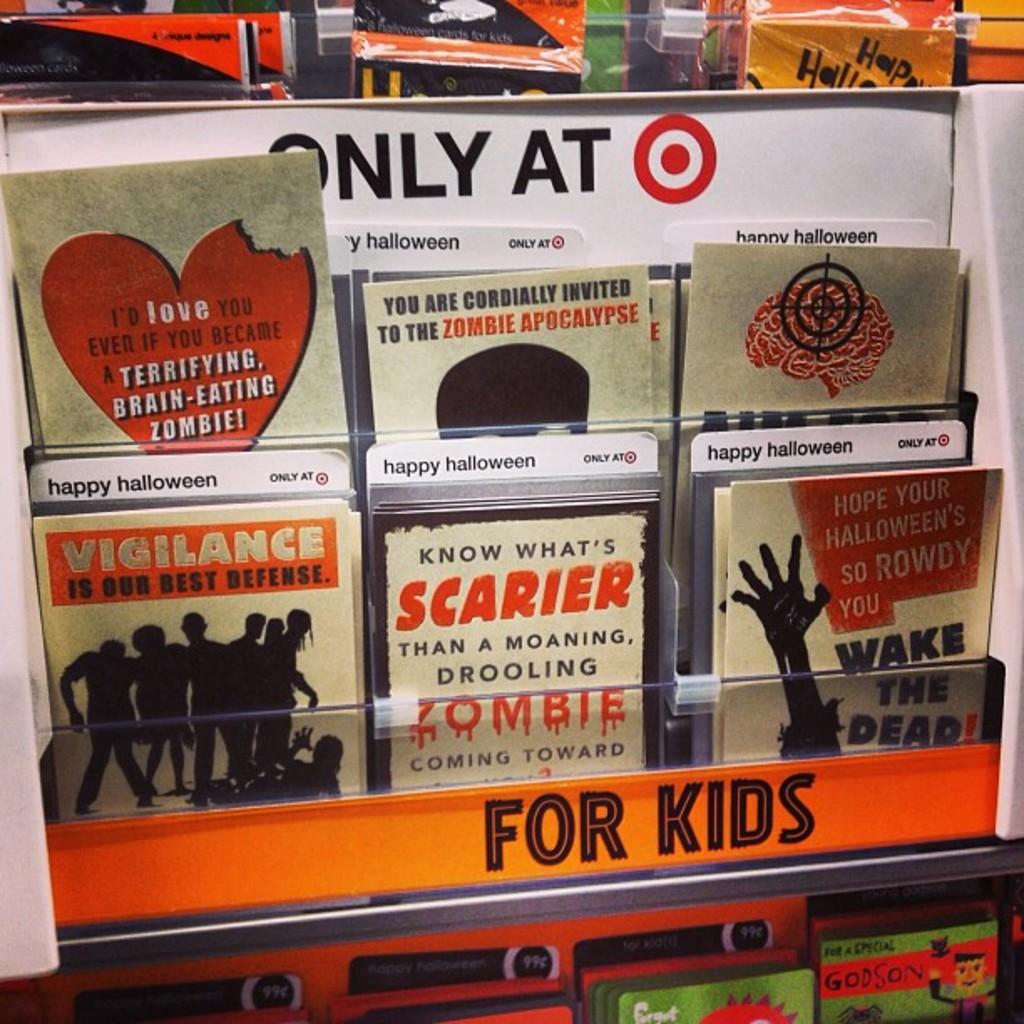What section is this for?
Your answer should be very brief. Kids. This is only at where?
Your answer should be very brief. Target. 